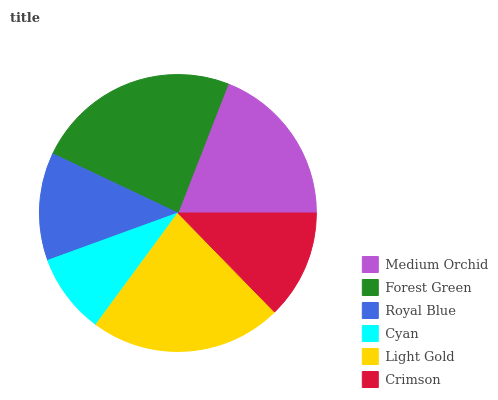Is Cyan the minimum?
Answer yes or no. Yes. Is Forest Green the maximum?
Answer yes or no. Yes. Is Royal Blue the minimum?
Answer yes or no. No. Is Royal Blue the maximum?
Answer yes or no. No. Is Forest Green greater than Royal Blue?
Answer yes or no. Yes. Is Royal Blue less than Forest Green?
Answer yes or no. Yes. Is Royal Blue greater than Forest Green?
Answer yes or no. No. Is Forest Green less than Royal Blue?
Answer yes or no. No. Is Medium Orchid the high median?
Answer yes or no. Yes. Is Crimson the low median?
Answer yes or no. Yes. Is Crimson the high median?
Answer yes or no. No. Is Light Gold the low median?
Answer yes or no. No. 